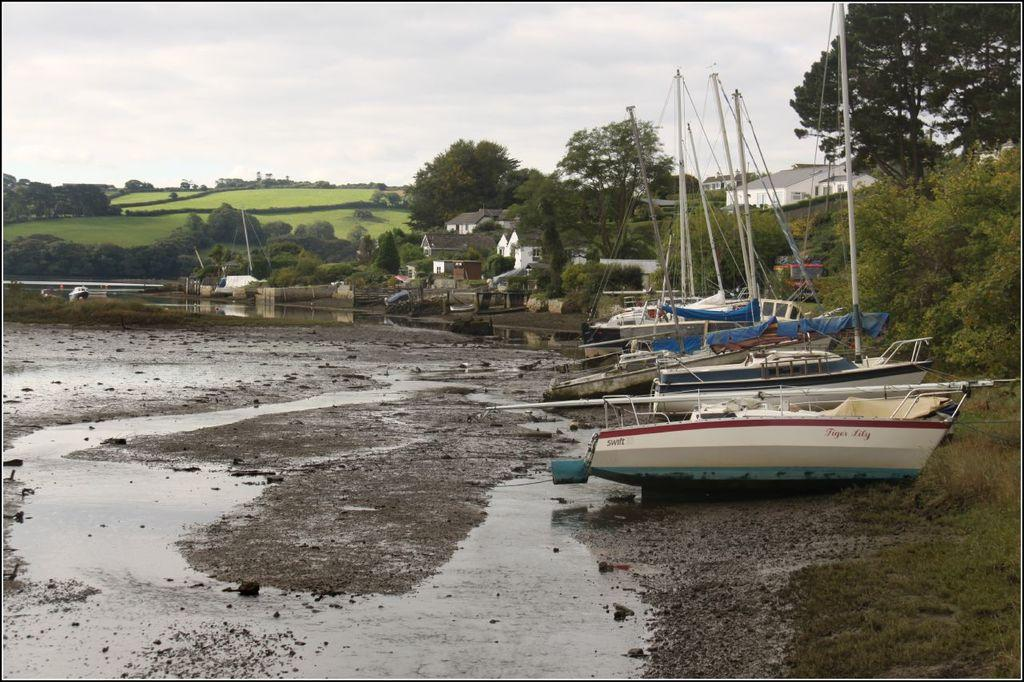What can be seen floating in the water in the image? There are boats in the image. What is the primary element that surrounds the boats? There is water visible in the image. What type of vegetation is present in the image? There are trees, plants, and grass in the image. What structures can be seen in the image? There are buildings in the image. What is visible in the sky in the image? There are clouds in the sky. What type of organization is depicted on the table in the image? There is no table or organization present in the image. Can you tell me how many mittens are visible in the image? There are no mittens present in the image. 